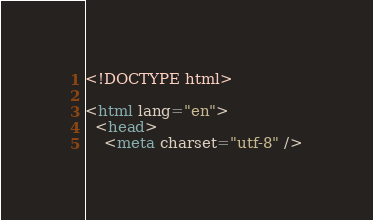<code> <loc_0><loc_0><loc_500><loc_500><_HTML_>
<!DOCTYPE html>

<html lang="en">
  <head>
    <meta charset="utf-8" /></code> 